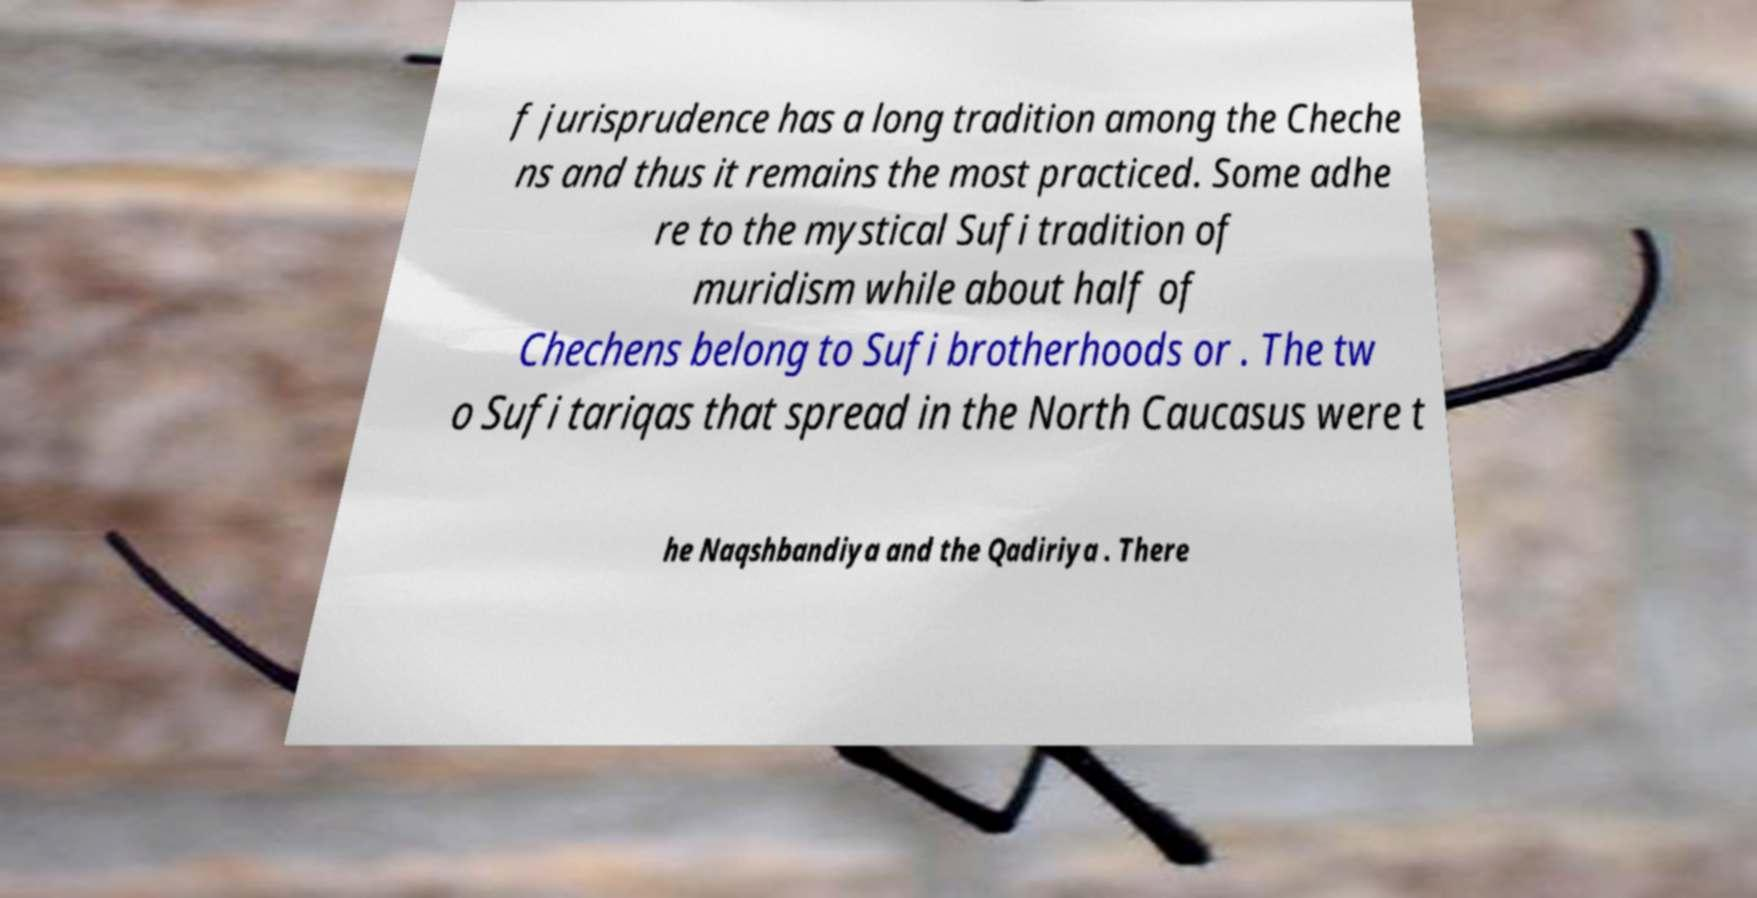Please identify and transcribe the text found in this image. f jurisprudence has a long tradition among the Cheche ns and thus it remains the most practiced. Some adhe re to the mystical Sufi tradition of muridism while about half of Chechens belong to Sufi brotherhoods or . The tw o Sufi tariqas that spread in the North Caucasus were t he Naqshbandiya and the Qadiriya . There 